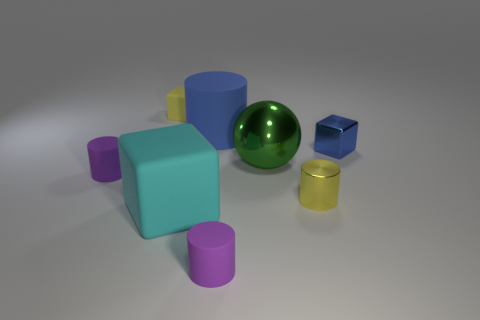Are there any other large matte things of the same shape as the cyan thing?
Your answer should be compact. No. Is there a blue object on the left side of the metal thing that is behind the green object?
Provide a succinct answer. Yes. What number of tiny cubes have the same material as the big blue cylinder?
Provide a short and direct response. 1. Are any large gray matte blocks visible?
Give a very brief answer. No. What number of metal blocks have the same color as the shiny cylinder?
Offer a terse response. 0. Is the material of the large sphere the same as the purple cylinder left of the big rubber cylinder?
Provide a succinct answer. No. Is the number of tiny yellow blocks that are in front of the yellow matte thing greater than the number of tiny shiny cubes?
Provide a short and direct response. No. Are there any other things that have the same size as the green object?
Offer a terse response. Yes. There is a metallic cylinder; is its color the same as the tiny object that is behind the small metallic cube?
Offer a terse response. Yes. Are there an equal number of cyan things on the left side of the yellow rubber cube and matte blocks that are in front of the small blue cube?
Offer a terse response. No. 